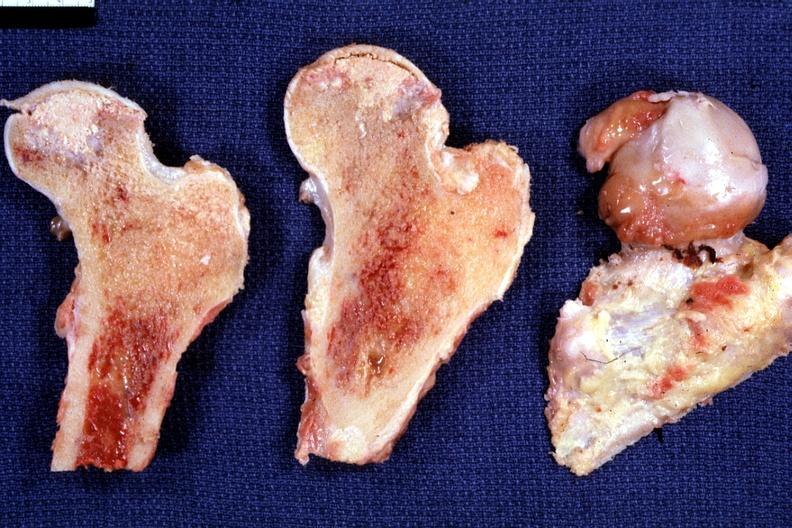s joints present?
Answer the question using a single word or phrase. Yes 